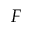Convert formula to latex. <formula><loc_0><loc_0><loc_500><loc_500>F</formula> 